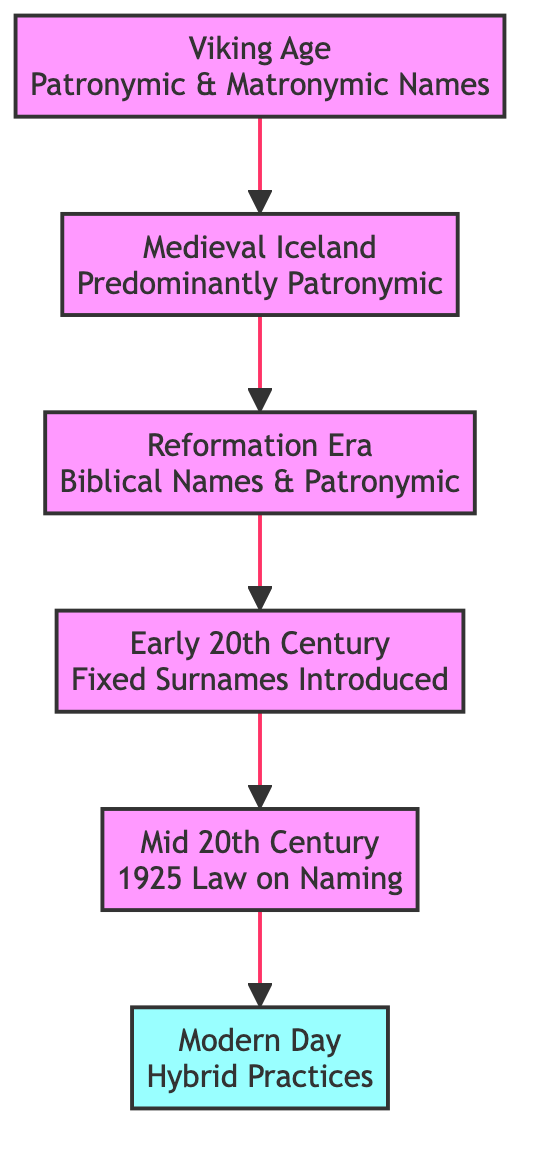What was the naming tradition during the Viking Age? The diagram states that during the Viking Age, patronymic and matronymic names were used, indicating a reliance on the names of the child's father or mother.
Answer: Patronymic and Matronymic Names How many main phases of Icelandic surname evolution are there in this diagram? By counting the stages represented in the diagram, there are a total of six phases: Viking Age, Medieval Iceland, Reformation Era, Early 20th Century, Mid 20th Century, and Modern Day.
Answer: 6 Which phase introduced fixed surnames? The diagram explicitly points out that the Early 20th Century phase includes the introduction of fixed surnames.
Answer: Early 20th Century What influence prompted the adoption of biblical names? The diagram highlights that the influence of Christianity during the Reformation Era led to the adoption of biblical names within Icelandic naming traditions.
Answer: Christianity Which stage sees the combination of traditional and modern practices? The Modern Day phase is where hybrid practices emerge, combining traditional naming conventions with modern influences due to globalization.
Answer: Modern Day What event in the Mid 20th Century impacted family surnames? According to the diagram, the passing of a law in 1925 restricted the adoption of new family surnames, ensuring widespread use of the traditional naming system.
Answer: Law passed in 1925 How does the transition from patronymic to modern naming practices progress? To answer this, one must follow the flow upwards from the Viking Age, where patronymic and matronymic names were used, to the Modern Day, where hybrid practices have emerged, indicating a gradual evolution influenced by various historical events.
Answer: Gradual evolution through historical influence What does the diagram say about matronymic names in the Medieval Iceland phase? The details specified in the Medieval Iceland phase state that matronymic names were less frequently used at that time, highlighting a shift towards patronymic naming.
Answer: Less frequently used 